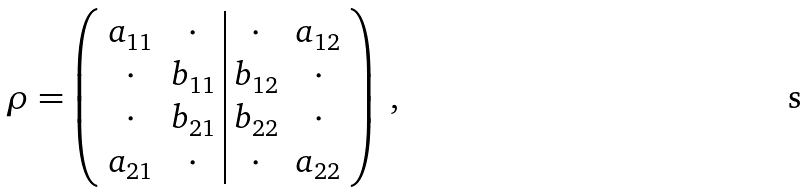Convert formula to latex. <formula><loc_0><loc_0><loc_500><loc_500>\rho = \left ( \begin{array} { c c | c c } a _ { 1 1 } & \cdot & \cdot & a _ { 1 2 } \\ \cdot & b _ { 1 1 } & b _ { 1 2 } & \cdot \\ \cdot & b _ { 2 1 } & b _ { 2 2 } & \cdot \\ a _ { 2 1 } & \cdot & \cdot & a _ { 2 2 } \end{array} \right ) \ ,</formula> 